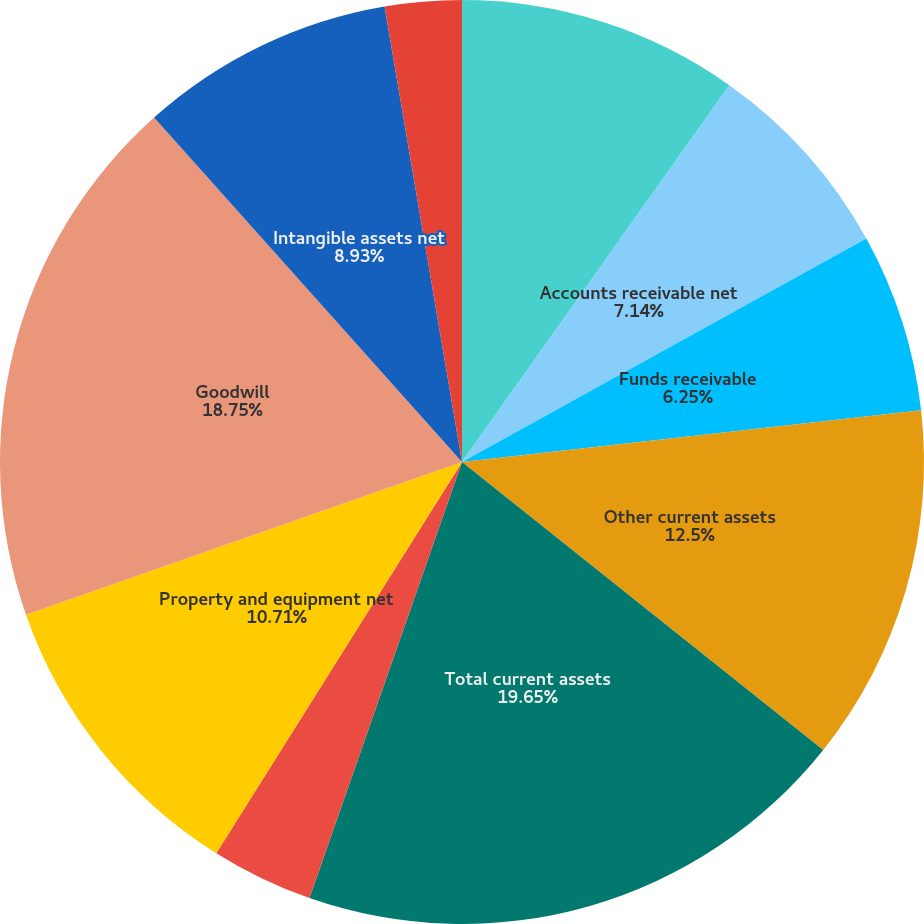Convert chart. <chart><loc_0><loc_0><loc_500><loc_500><pie_chart><fcel>Short-term investments<fcel>Accounts receivable net<fcel>Funds receivable<fcel>Other current assets<fcel>Total current assets<fcel>Long-term investments<fcel>Property and equipment net<fcel>Goodwill<fcel>Intangible assets net<fcel>Other assets<nl><fcel>9.82%<fcel>7.14%<fcel>6.25%<fcel>12.5%<fcel>19.64%<fcel>3.57%<fcel>10.71%<fcel>18.75%<fcel>8.93%<fcel>2.68%<nl></chart> 